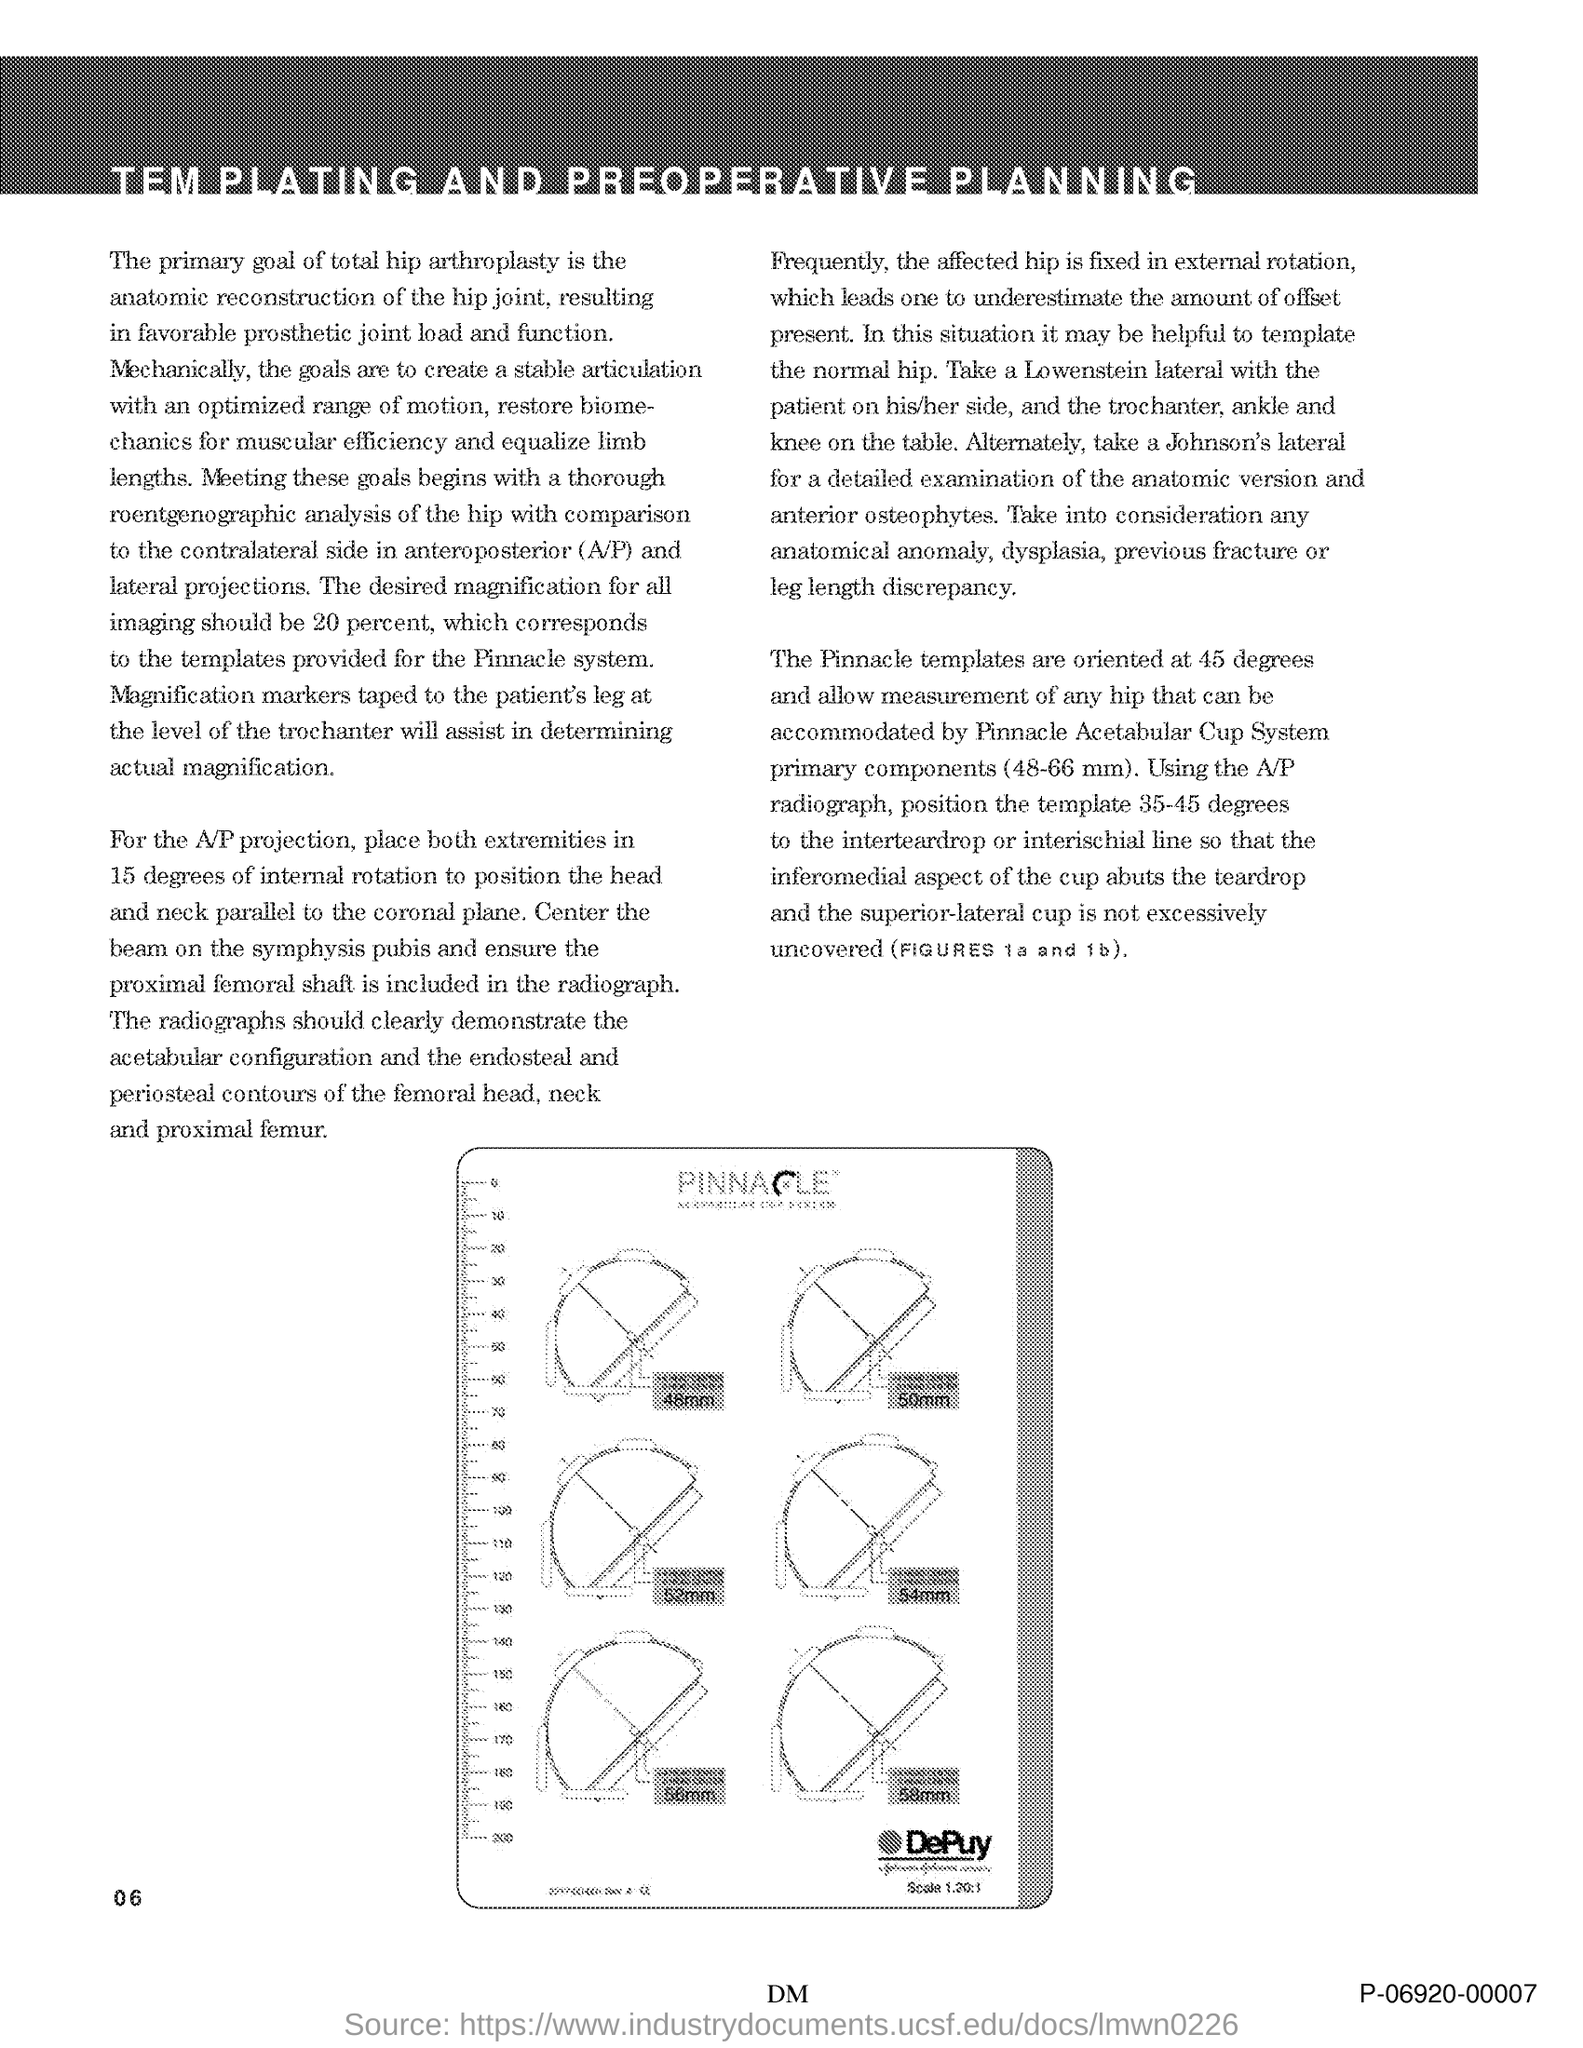Highlight a few significant elements in this photo. The acetabular configuration can be clearly demonstrated through radiographs, as they provide visual evidence of the shape and size of the acetabulum. The Pinnacle templates are oriented at a 45-degree angle. 